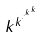<formula> <loc_0><loc_0><loc_500><loc_500>k ^ { k ^ { \cdot ^ { \cdot ^ { k ^ { k } } } } }</formula> 